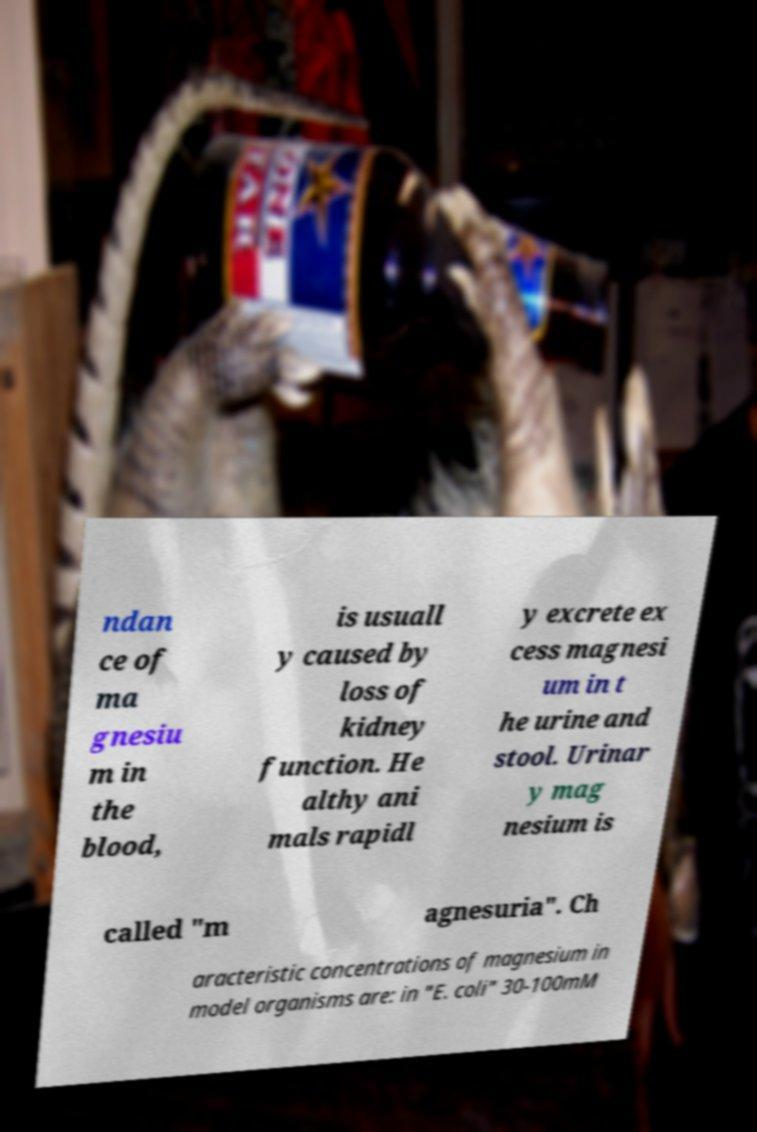There's text embedded in this image that I need extracted. Can you transcribe it verbatim? ndan ce of ma gnesiu m in the blood, is usuall y caused by loss of kidney function. He althy ani mals rapidl y excrete ex cess magnesi um in t he urine and stool. Urinar y mag nesium is called "m agnesuria". Ch aracteristic concentrations of magnesium in model organisms are: in "E. coli" 30-100mM 